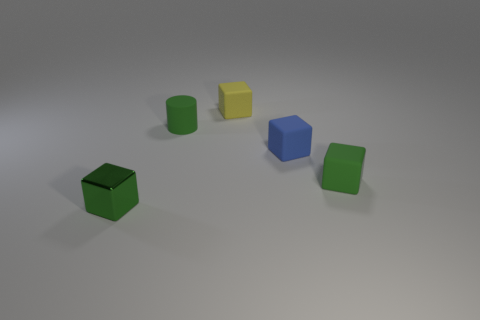What is the color of the tiny cube that is in front of the green thing to the right of the tiny blue rubber cube?
Your answer should be compact. Green. What color is the cylinder that is the same size as the shiny object?
Give a very brief answer. Green. What number of small blocks are both on the left side of the tiny cylinder and behind the green shiny thing?
Keep it short and to the point. 0. What shape is the small matte thing that is the same color as the cylinder?
Keep it short and to the point. Cube. There is a object that is both left of the yellow thing and in front of the tiny matte cylinder; what material is it?
Make the answer very short. Metal. Are there fewer blue cubes that are left of the tiny blue rubber cube than small blue things that are left of the green rubber cube?
Offer a terse response. Yes. What size is the blue thing that is the same material as the small cylinder?
Offer a very short reply. Small. Is the cylinder made of the same material as the small green cube that is to the left of the tiny green rubber cylinder?
Provide a succinct answer. No. Is the material of the green thing that is behind the tiny blue object the same as the block that is left of the tiny yellow matte thing?
Keep it short and to the point. No. The metallic cube on the left side of the small thing behind the tiny green thing that is behind the blue thing is what color?
Keep it short and to the point. Green. 